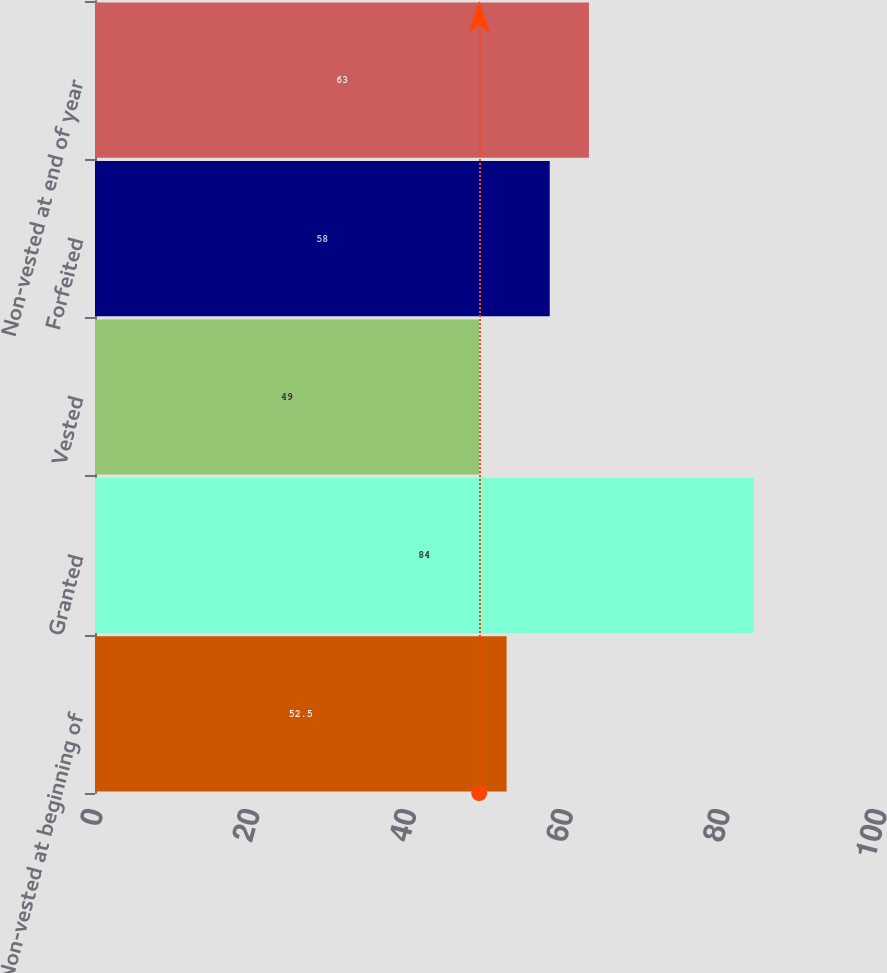Convert chart. <chart><loc_0><loc_0><loc_500><loc_500><bar_chart><fcel>Non-vested at beginning of<fcel>Granted<fcel>Vested<fcel>Forfeited<fcel>Non-vested at end of year<nl><fcel>52.5<fcel>84<fcel>49<fcel>58<fcel>63<nl></chart> 